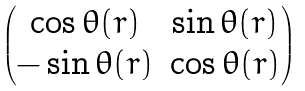Convert formula to latex. <formula><loc_0><loc_0><loc_500><loc_500>\begin{pmatrix} \cos \theta ( r ) & \sin \theta ( r ) \\ - \sin \theta ( r ) & \cos \theta ( r ) \end{pmatrix}</formula> 